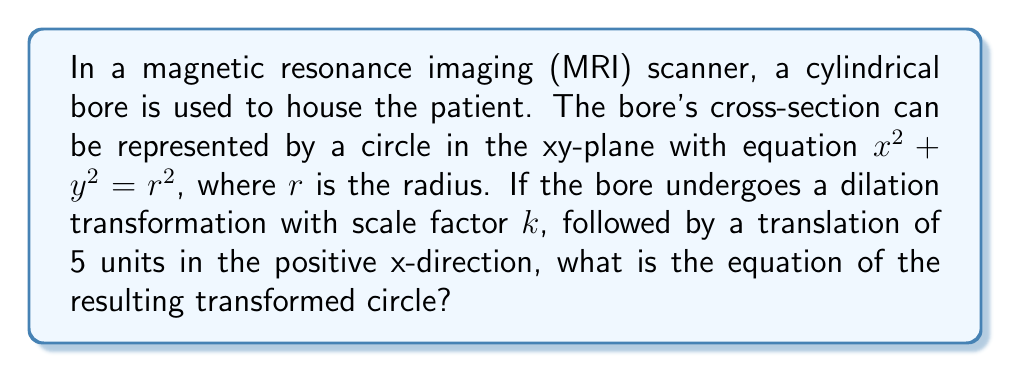Can you answer this question? Let's approach this step-by-step:

1) The original equation of the circle is:
   $$x^2 + y^2 = r^2$$

2) First, we apply the dilation transformation with scale factor $k$. This transforms every point $(x, y)$ to $(kx, ky)$. Substituting these into the original equation:
   $$(kx)^2 + (ky)^2 = (kr)^2$$

3) Simplifying:
   $$k^2x^2 + k^2y^2 = k^2r^2$$
   $$x^2 + y^2 = r^2$$ (dividing both sides by $k^2$)

4) Now, we apply the translation of 5 units in the positive x-direction. This transforms every point $(x, y)$ to $(x-5, y)$. Substituting these into our equation:
   $$(x-5)^2 + y^2 = r^2$$

5) Expanding the squared term:
   $$x^2 - 10x + 25 + y^2 = r^2$$

6) Rearranging to standard form:
   $$x^2 + y^2 - 10x = r^2 - 25$$

7) Completing the square for x:
   $$(x^2 - 10x + 25) + y^2 = r^2$$
   $$(x - 5)^2 + y^2 = r^2$$

This is the equation of the transformed circle.
Answer: $(x - 5)^2 + y^2 = r^2$ 